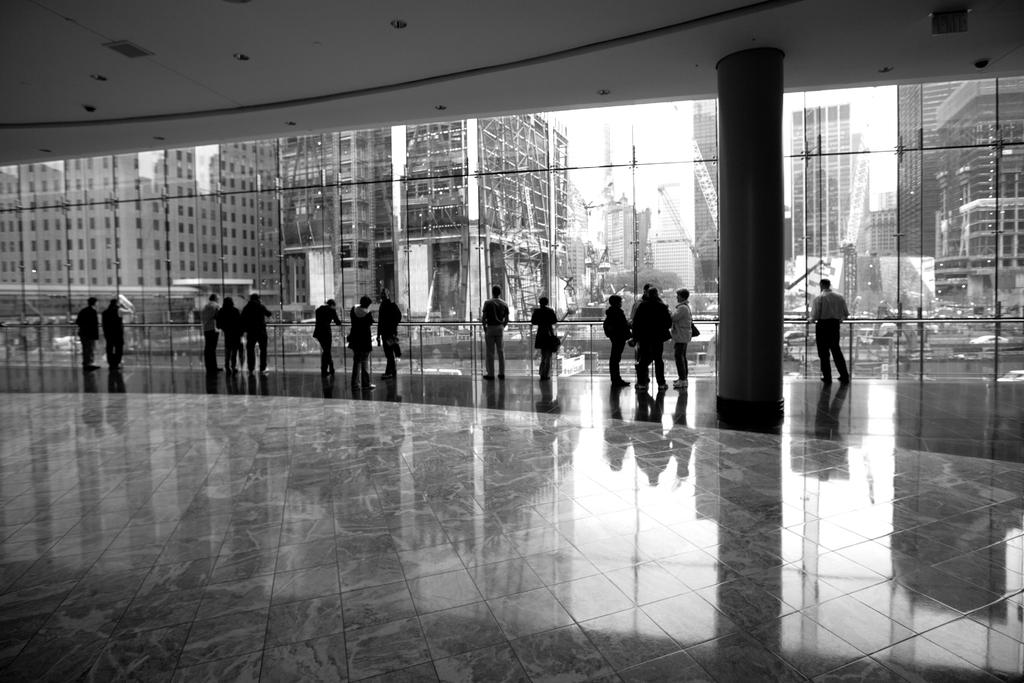What is the color scheme of the image? The image is in black and white. What can be seen on the floor in the image? There are many people standing on the floor. What is separating the people from the background? The people are in front of glass panes. What can be seen in the distance behind the glass panes? There are buildings visible in the background. Can you hear the bats talking to each other in the image? There are no bats or talking sounds present in the image. 